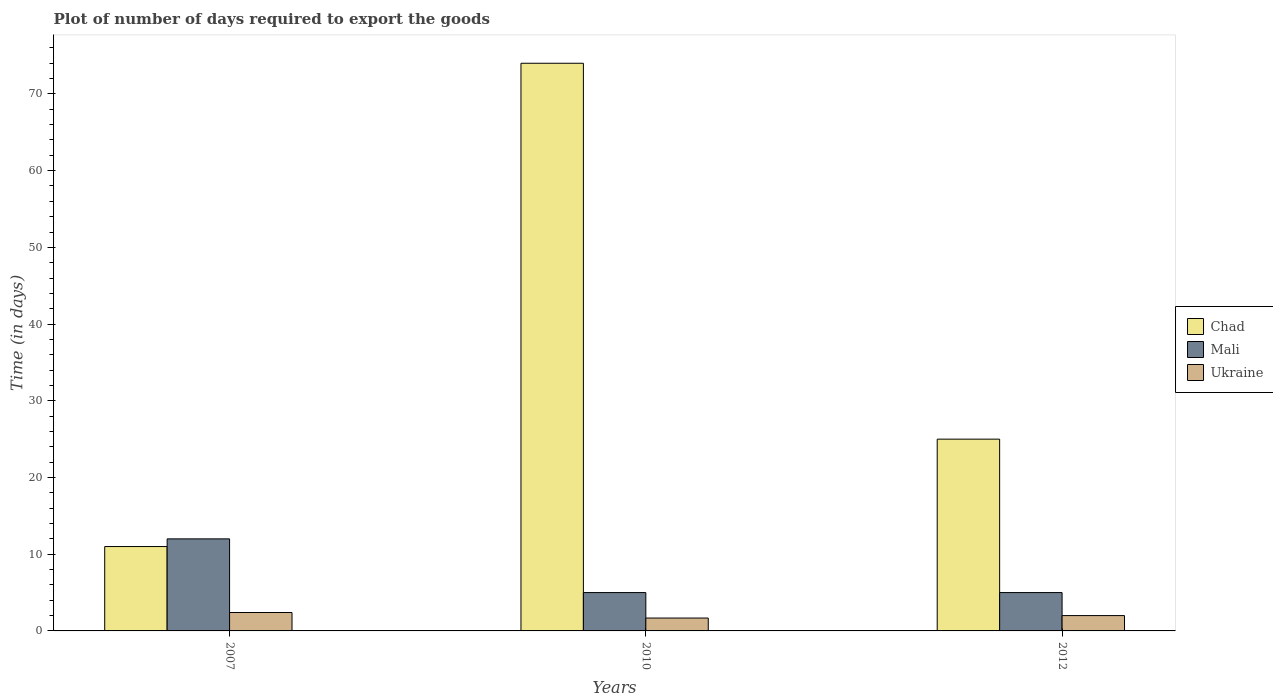How many different coloured bars are there?
Make the answer very short. 3. How many bars are there on the 2nd tick from the left?
Ensure brevity in your answer.  3. What is the label of the 2nd group of bars from the left?
Your answer should be very brief. 2010. In how many cases, is the number of bars for a given year not equal to the number of legend labels?
Keep it short and to the point. 0. What is the time required to export goods in Ukraine in 2010?
Offer a very short reply. 1.68. Across all years, what is the maximum time required to export goods in Chad?
Offer a terse response. 74. Across all years, what is the minimum time required to export goods in Ukraine?
Your answer should be very brief. 1.68. What is the total time required to export goods in Chad in the graph?
Your answer should be compact. 110. What is the difference between the time required to export goods in Ukraine in 2007 and that in 2012?
Make the answer very short. 0.4. What is the difference between the time required to export goods in Mali in 2007 and the time required to export goods in Ukraine in 2012?
Offer a very short reply. 10. What is the average time required to export goods in Mali per year?
Offer a very short reply. 7.33. In the year 2007, what is the difference between the time required to export goods in Ukraine and time required to export goods in Mali?
Your answer should be very brief. -9.6. What is the ratio of the time required to export goods in Ukraine in 2010 to that in 2012?
Your answer should be compact. 0.84. What is the difference between the highest and the lowest time required to export goods in Chad?
Offer a terse response. 63. In how many years, is the time required to export goods in Ukraine greater than the average time required to export goods in Ukraine taken over all years?
Make the answer very short. 1. Is the sum of the time required to export goods in Chad in 2010 and 2012 greater than the maximum time required to export goods in Ukraine across all years?
Make the answer very short. Yes. What does the 1st bar from the left in 2007 represents?
Give a very brief answer. Chad. What does the 2nd bar from the right in 2012 represents?
Give a very brief answer. Mali. Are all the bars in the graph horizontal?
Offer a terse response. No. How many years are there in the graph?
Provide a succinct answer. 3. Does the graph contain grids?
Provide a succinct answer. No. Where does the legend appear in the graph?
Keep it short and to the point. Center right. How are the legend labels stacked?
Provide a succinct answer. Vertical. What is the title of the graph?
Make the answer very short. Plot of number of days required to export the goods. Does "Saudi Arabia" appear as one of the legend labels in the graph?
Your response must be concise. No. What is the label or title of the X-axis?
Give a very brief answer. Years. What is the label or title of the Y-axis?
Provide a short and direct response. Time (in days). What is the Time (in days) in Chad in 2007?
Offer a very short reply. 11. What is the Time (in days) of Ukraine in 2007?
Provide a short and direct response. 2.4. What is the Time (in days) in Chad in 2010?
Offer a very short reply. 74. What is the Time (in days) of Mali in 2010?
Provide a short and direct response. 5. What is the Time (in days) in Ukraine in 2010?
Provide a short and direct response. 1.68. What is the Time (in days) of Chad in 2012?
Ensure brevity in your answer.  25. Across all years, what is the maximum Time (in days) of Chad?
Provide a succinct answer. 74. Across all years, what is the minimum Time (in days) in Ukraine?
Make the answer very short. 1.68. What is the total Time (in days) in Chad in the graph?
Make the answer very short. 110. What is the total Time (in days) of Mali in the graph?
Make the answer very short. 22. What is the total Time (in days) in Ukraine in the graph?
Give a very brief answer. 6.08. What is the difference between the Time (in days) in Chad in 2007 and that in 2010?
Your answer should be compact. -63. What is the difference between the Time (in days) in Mali in 2007 and that in 2010?
Provide a succinct answer. 7. What is the difference between the Time (in days) of Ukraine in 2007 and that in 2010?
Your response must be concise. 0.72. What is the difference between the Time (in days) of Ukraine in 2007 and that in 2012?
Give a very brief answer. 0.4. What is the difference between the Time (in days) of Chad in 2010 and that in 2012?
Ensure brevity in your answer.  49. What is the difference between the Time (in days) in Mali in 2010 and that in 2012?
Give a very brief answer. 0. What is the difference between the Time (in days) in Ukraine in 2010 and that in 2012?
Your response must be concise. -0.32. What is the difference between the Time (in days) in Chad in 2007 and the Time (in days) in Ukraine in 2010?
Keep it short and to the point. 9.32. What is the difference between the Time (in days) of Mali in 2007 and the Time (in days) of Ukraine in 2010?
Offer a terse response. 10.32. What is the difference between the Time (in days) of Chad in 2007 and the Time (in days) of Mali in 2012?
Provide a short and direct response. 6. What is the difference between the Time (in days) in Chad in 2010 and the Time (in days) in Ukraine in 2012?
Give a very brief answer. 72. What is the average Time (in days) of Chad per year?
Ensure brevity in your answer.  36.67. What is the average Time (in days) of Mali per year?
Make the answer very short. 7.33. What is the average Time (in days) of Ukraine per year?
Offer a terse response. 2.03. In the year 2007, what is the difference between the Time (in days) in Chad and Time (in days) in Mali?
Provide a succinct answer. -1. In the year 2007, what is the difference between the Time (in days) in Chad and Time (in days) in Ukraine?
Your answer should be compact. 8.6. In the year 2007, what is the difference between the Time (in days) in Mali and Time (in days) in Ukraine?
Your answer should be compact. 9.6. In the year 2010, what is the difference between the Time (in days) of Chad and Time (in days) of Ukraine?
Offer a very short reply. 72.32. In the year 2010, what is the difference between the Time (in days) in Mali and Time (in days) in Ukraine?
Offer a terse response. 3.32. In the year 2012, what is the difference between the Time (in days) in Chad and Time (in days) in Ukraine?
Your answer should be very brief. 23. In the year 2012, what is the difference between the Time (in days) of Mali and Time (in days) of Ukraine?
Your answer should be compact. 3. What is the ratio of the Time (in days) in Chad in 2007 to that in 2010?
Make the answer very short. 0.15. What is the ratio of the Time (in days) in Ukraine in 2007 to that in 2010?
Your response must be concise. 1.43. What is the ratio of the Time (in days) of Chad in 2007 to that in 2012?
Make the answer very short. 0.44. What is the ratio of the Time (in days) in Mali in 2007 to that in 2012?
Your answer should be compact. 2.4. What is the ratio of the Time (in days) of Chad in 2010 to that in 2012?
Give a very brief answer. 2.96. What is the ratio of the Time (in days) of Mali in 2010 to that in 2012?
Keep it short and to the point. 1. What is the ratio of the Time (in days) in Ukraine in 2010 to that in 2012?
Your answer should be very brief. 0.84. What is the difference between the highest and the second highest Time (in days) in Chad?
Provide a succinct answer. 49. What is the difference between the highest and the second highest Time (in days) of Mali?
Your answer should be very brief. 7. What is the difference between the highest and the second highest Time (in days) in Ukraine?
Provide a short and direct response. 0.4. What is the difference between the highest and the lowest Time (in days) in Chad?
Your response must be concise. 63. What is the difference between the highest and the lowest Time (in days) in Ukraine?
Your response must be concise. 0.72. 